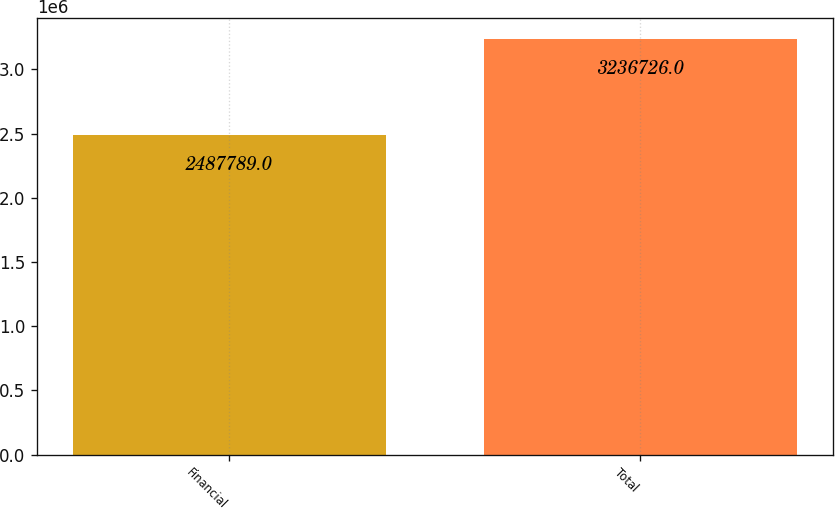<chart> <loc_0><loc_0><loc_500><loc_500><bar_chart><fcel>Financial<fcel>Total<nl><fcel>2.48779e+06<fcel>3.23673e+06<nl></chart> 